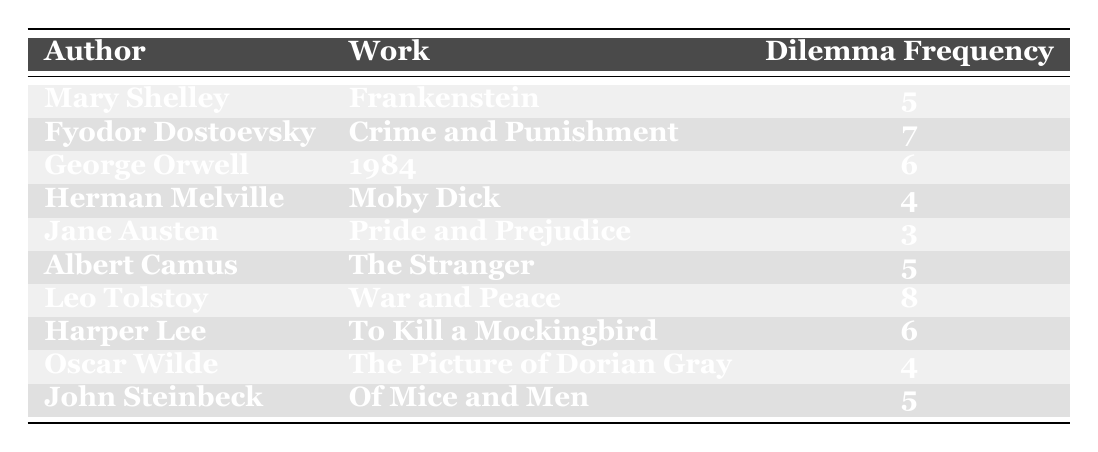What is the highest frequency of ethical dilemmas presented by an author? The table shows the dilemma frequency for each author. By examining the values, Leo Tolstoy has the highest frequency at 8.
Answer: 8 Which author has the lowest frequency of ethical dilemmas? From the table, Jane Austen has the lowest frequency of ethical dilemmas, which is 3.
Answer: 3 What is the total frequency of ethical dilemmas across all authors? To find the total, we add up all the frequencies: 5 + 7 + 6 + 4 + 3 + 5 + 8 + 6 + 4 + 5 = 53.
Answer: 53 How many authors have a dilemma frequency of 5? By counting the rows where the frequency is 5, we find that there are three authors: Mary Shelley, Albert Camus, and John Steinbeck.
Answer: 3 Is it true that both George Orwell and Harper Lee have the same dilemma frequency? Checking the frequencies for both authors: George Orwell has a frequency of 6, and Harper Lee also has a frequency of 6, so the statement is true.
Answer: Yes Which two authors have the same dilemma frequency of 4? Looking at the table, the authors with a frequency of 4 are Herman Melville and Oscar Wilde.
Answer: Herman Melville and Oscar Wilde What is the average frequency of ethical dilemmas for the authors in the table? There are 10 authors, and the total frequency is 53. To find the average, we divide the total frequency (53) by the number of authors (10): 53/10 = 5.3.
Answer: 5.3 Which author presented more ethical dilemmas: Fyodor Dostoevsky or George Orwell? Fyodor Dostoevsky has a frequency of 7, while George Orwell has a frequency of 6. Since 7 is greater than 6, Dostoevsky presented more dilemmas.
Answer: Fyodor Dostoevsky How many authors have a higher frequency of ethical dilemmas than Jane Austen? Jane Austen has a frequency of 3. The authors with higher frequencies are Mary Shelley (5), Fyodor Dostoevsky (7), George Orwell (6), Leo Tolstoy (8), Albert Camus (5), Harper Lee (6), and John Steinbeck (5). Counting these gives us 7 authors.
Answer: 7 